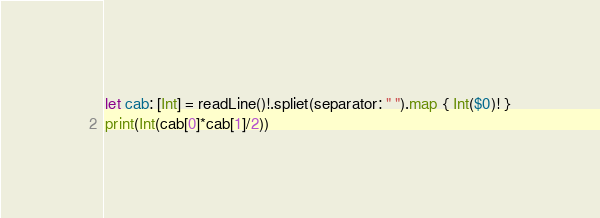Convert code to text. <code><loc_0><loc_0><loc_500><loc_500><_Swift_>let cab: [Int] = readLine()!.spliet(separator: " ").map { Int($0)! }
print(Int(cab[0]*cab[1]/2))</code> 